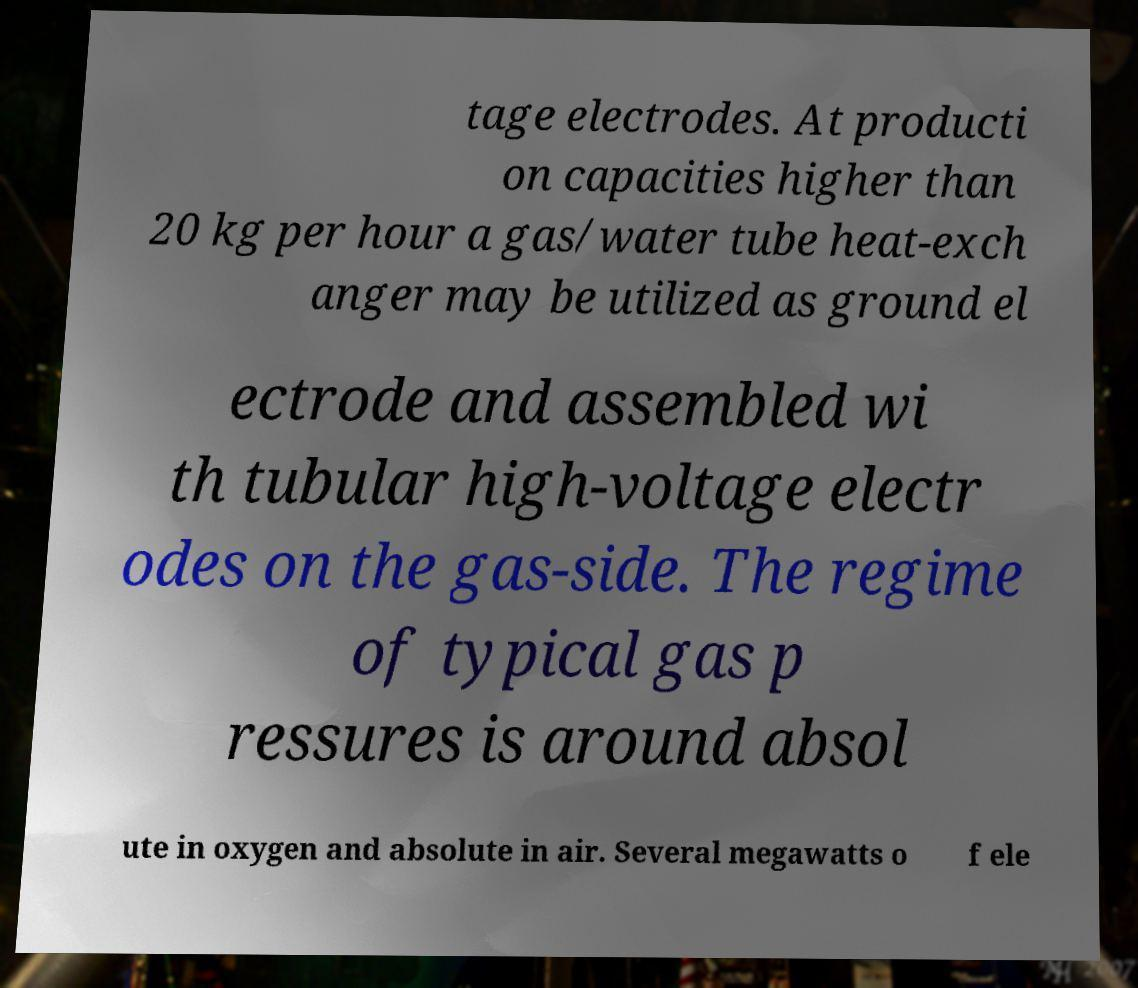Can you read and provide the text displayed in the image?This photo seems to have some interesting text. Can you extract and type it out for me? tage electrodes. At producti on capacities higher than 20 kg per hour a gas/water tube heat-exch anger may be utilized as ground el ectrode and assembled wi th tubular high-voltage electr odes on the gas-side. The regime of typical gas p ressures is around absol ute in oxygen and absolute in air. Several megawatts o f ele 